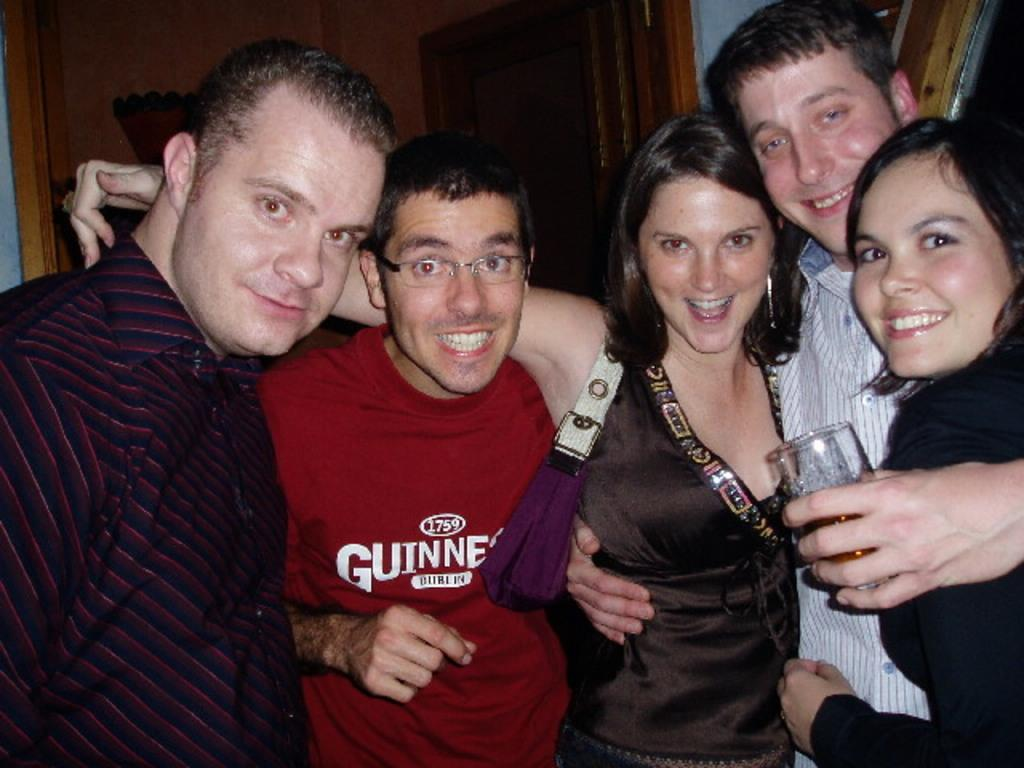How many individuals are present in the image? There are five people in the image. Can you describe the gender distribution among the people? Three of the people are men, and two of the people are women. What are the people in the image doing? The people are standing and posing for the picture. What flavor of ice cream is being held by the clock in the image? There is no ice cream or clock present in the image. 